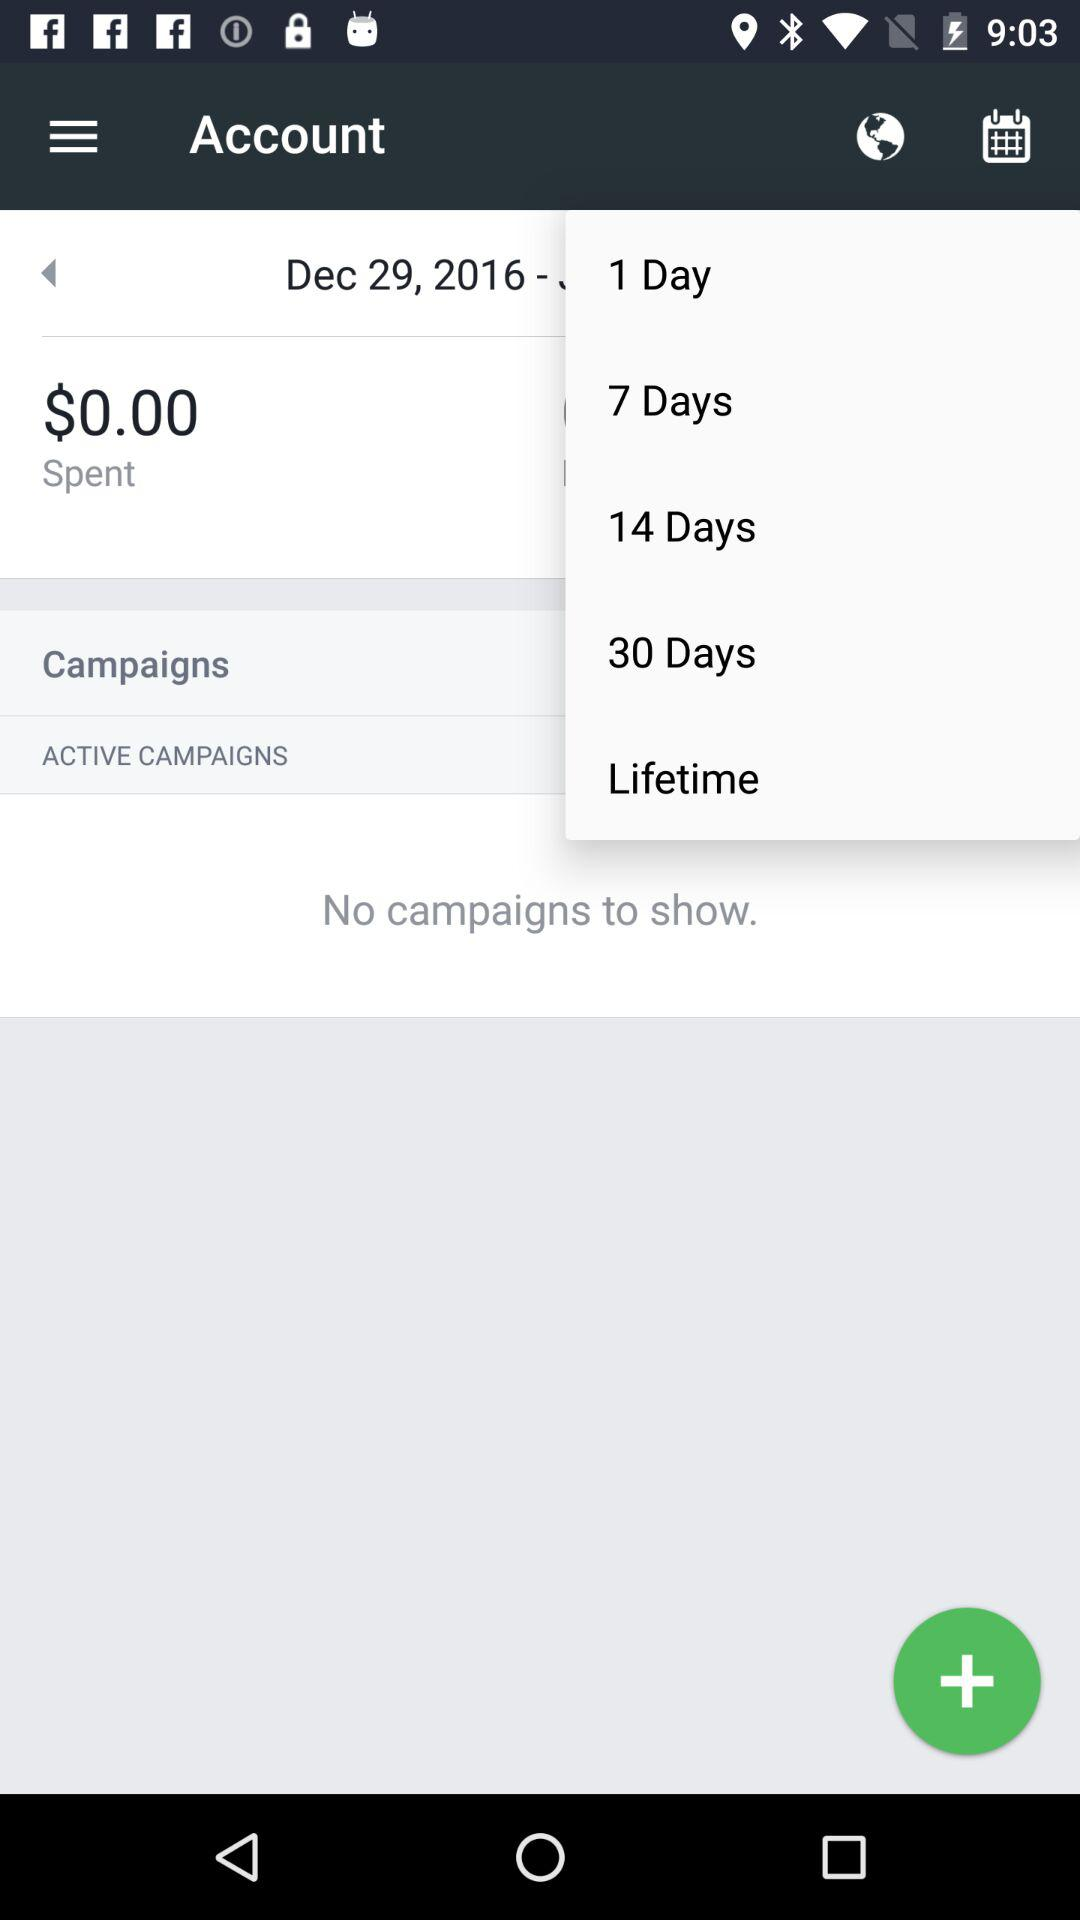What is the date? The date is December 29, 2016. 